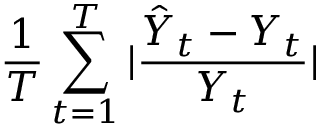Convert formula to latex. <formula><loc_0><loc_0><loc_500><loc_500>\frac { 1 } { T } \sum _ { t = 1 } ^ { T } | \frac { \hat { Y } _ { t } - Y _ { t } } { Y _ { t } } |</formula> 